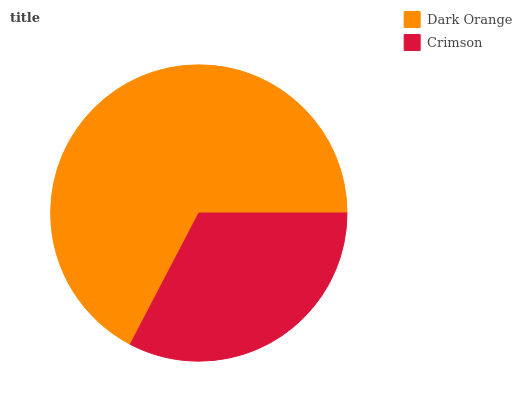Is Crimson the minimum?
Answer yes or no. Yes. Is Dark Orange the maximum?
Answer yes or no. Yes. Is Crimson the maximum?
Answer yes or no. No. Is Dark Orange greater than Crimson?
Answer yes or no. Yes. Is Crimson less than Dark Orange?
Answer yes or no. Yes. Is Crimson greater than Dark Orange?
Answer yes or no. No. Is Dark Orange less than Crimson?
Answer yes or no. No. Is Dark Orange the high median?
Answer yes or no. Yes. Is Crimson the low median?
Answer yes or no. Yes. Is Crimson the high median?
Answer yes or no. No. Is Dark Orange the low median?
Answer yes or no. No. 